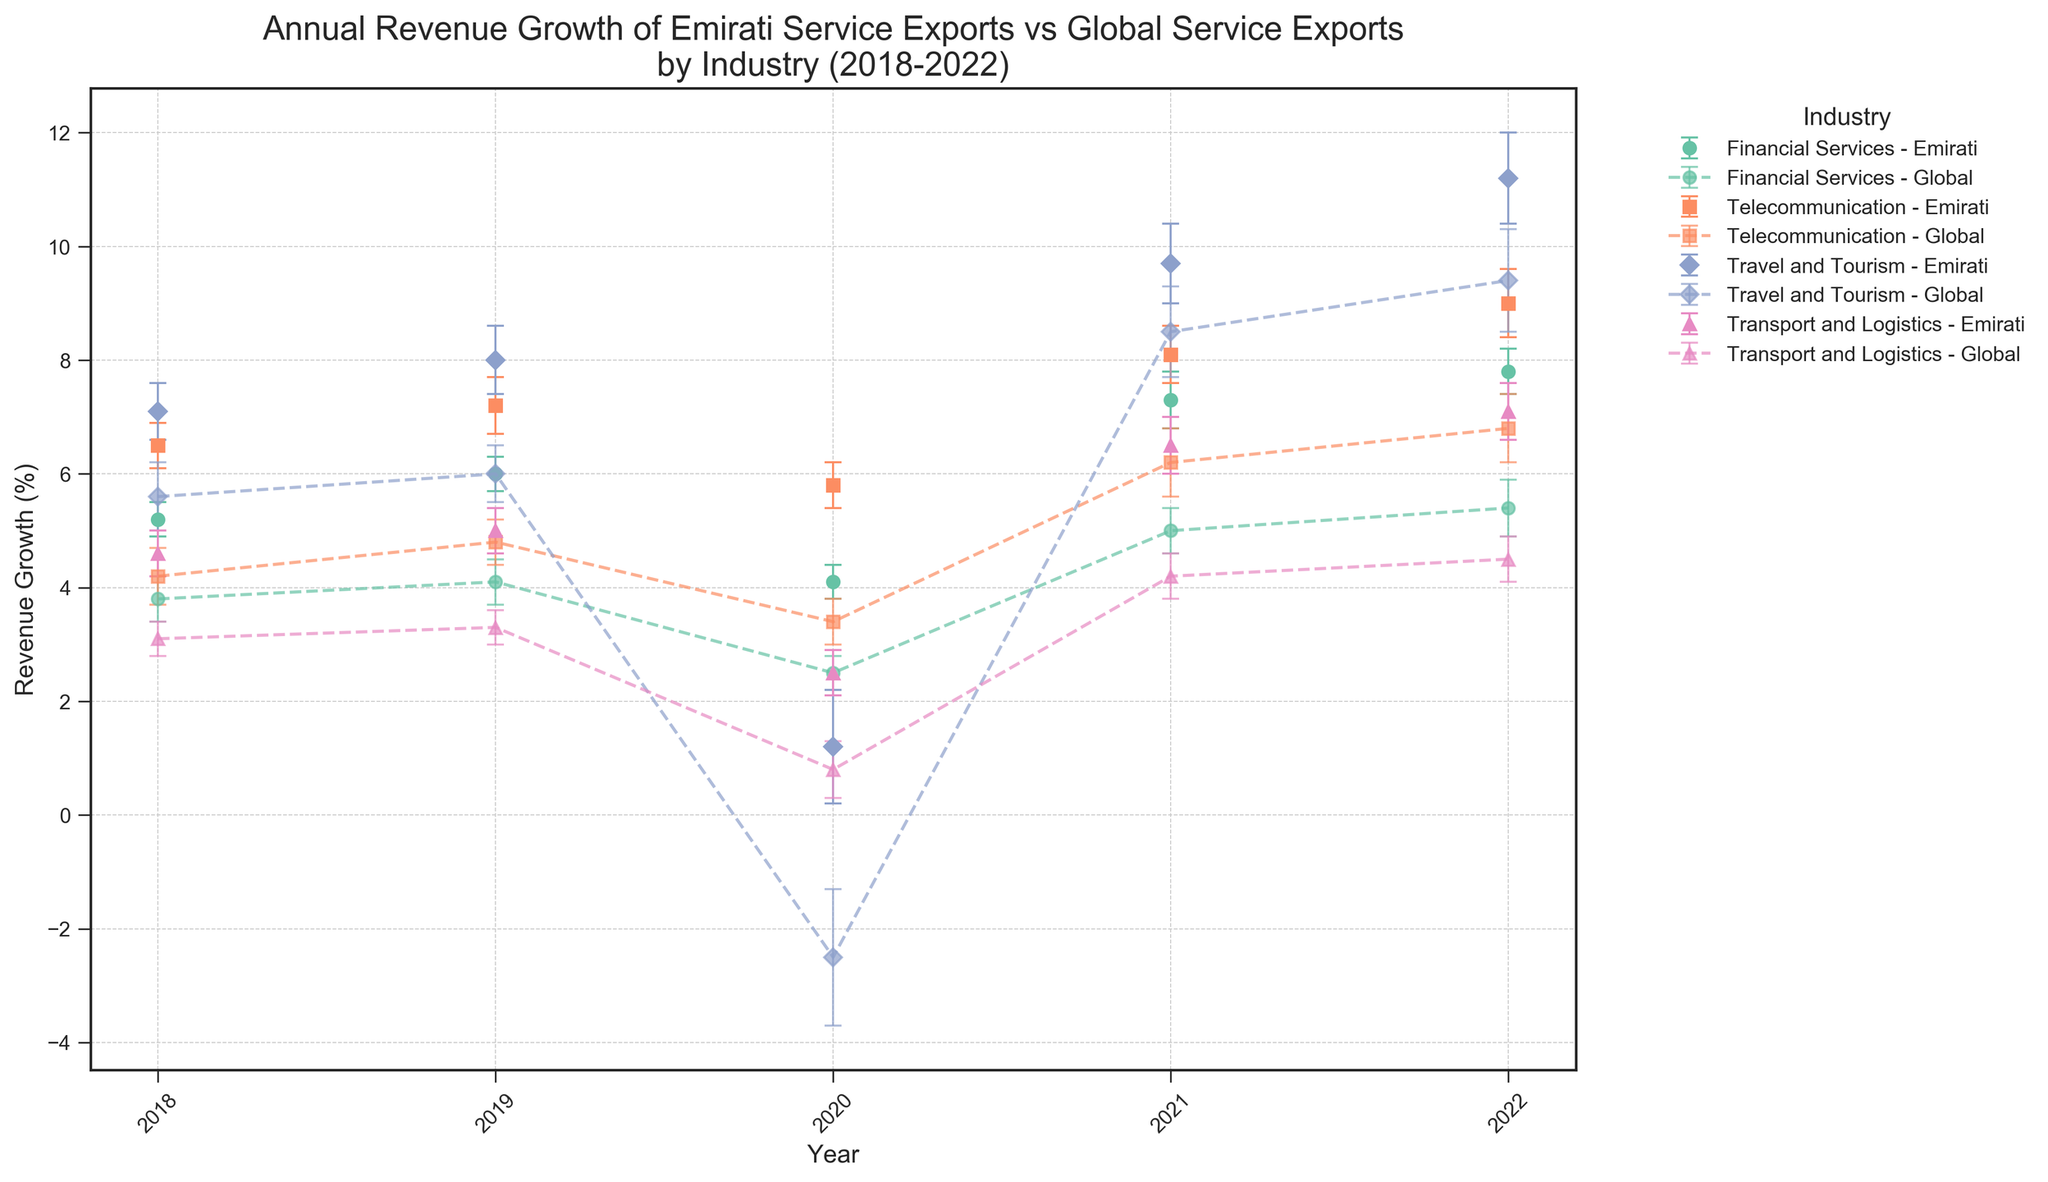What's the overall trend of Emirati service exports revenue growth in the Financial Services industry between 2018 and 2022? The chart shows the year-over-year revenue growth for Emirati service exports in the Financial Services industry using lines and markers. From 2018 to 2022, the Emirati service exports in Financial Services exhibit a general upward trend, with a slight dip in 2020 followed by an increase through 2022.
Answer: Upward trend How does the revenue growth of Emirati Telecommunication service exports in 2020 compare to the global counterparts? By observing the positions of the markers and error bars for 2020, Emirati Telecommunication service exports grew by 5.8% while the global Telecommunication service exports grew by 3.4%. Even considering the error margins, Emirati growth is higher.
Answer: Emirati growth is higher Which industry experienced the largest decline in Emirati service export revenue growth in 2020? By examining the dip in the markers in 2020 for each industry in the Emirati service exports curve, it's evident that Travel and Tourism had the steepest decline, dropping significantly in growth compared to previous years.
Answer: Travel and Tourism Between 2021 and 2022, which industry's Emirati service exports showed the highest increase in revenue growth? Comparing the differences in heights of the markers between 2021 and 2022 for each industry curve, Travel and Tourism displays the largest increase in revenue growth for Emirati service exports.
Answer: Travel and Tourism In 2022, how did the revenue growth of Emirati Travel and Tourism service exports compare to the global Travel and Tourism service exports? The chart's markers for 2022 indicate Emirati Travel and Tourism service export growth is 11.2% with an error margin of 0.8%, while the global counterpart stands at 9.4% with an error margin of 0.9%. Emirati growth is higher, taking error margins into account.
Answer: Emirati growth is higher What's the difference between Emirati and global revenue growth in the Transport and Logistics industry in 2019? Referring to the markers for 2019, Emirati service exports in Transport and Logistics grew by 5.0%, while the global growth was 3.3%. Calculating the difference: 5.0% - 3.3% = 1.7%.
Answer: 1.7% Which year showed the smallest difference between Emirati and global service export growth in the Financial Services industry? By examining the distances between the paired markers for each year in the Financial Services curve, 2018 shows the smallest difference between Emirati growth (5.2%) and global growth (3.8%).
Answer: 2018 Comparing the error margins across all years, in which year did the Emirati Travel and Tourism industry have the highest relative uncertainty? Looking for the year with the highest error bar relative to its data point in the Emirati Travel and Tourism curve, 2020 stands out with an error margin of 1.0%.
Answer: 2020 How did the revenue growth in Emirati Financial Services change from 2020 to 2021? Observing the markers, Emirati Financial Services grew from 4.1% in 2020 to 7.3% in 2021. Calculate the change: 7.3% - 4.1% = 3.2%.
Answer: Increased by 3.2% 